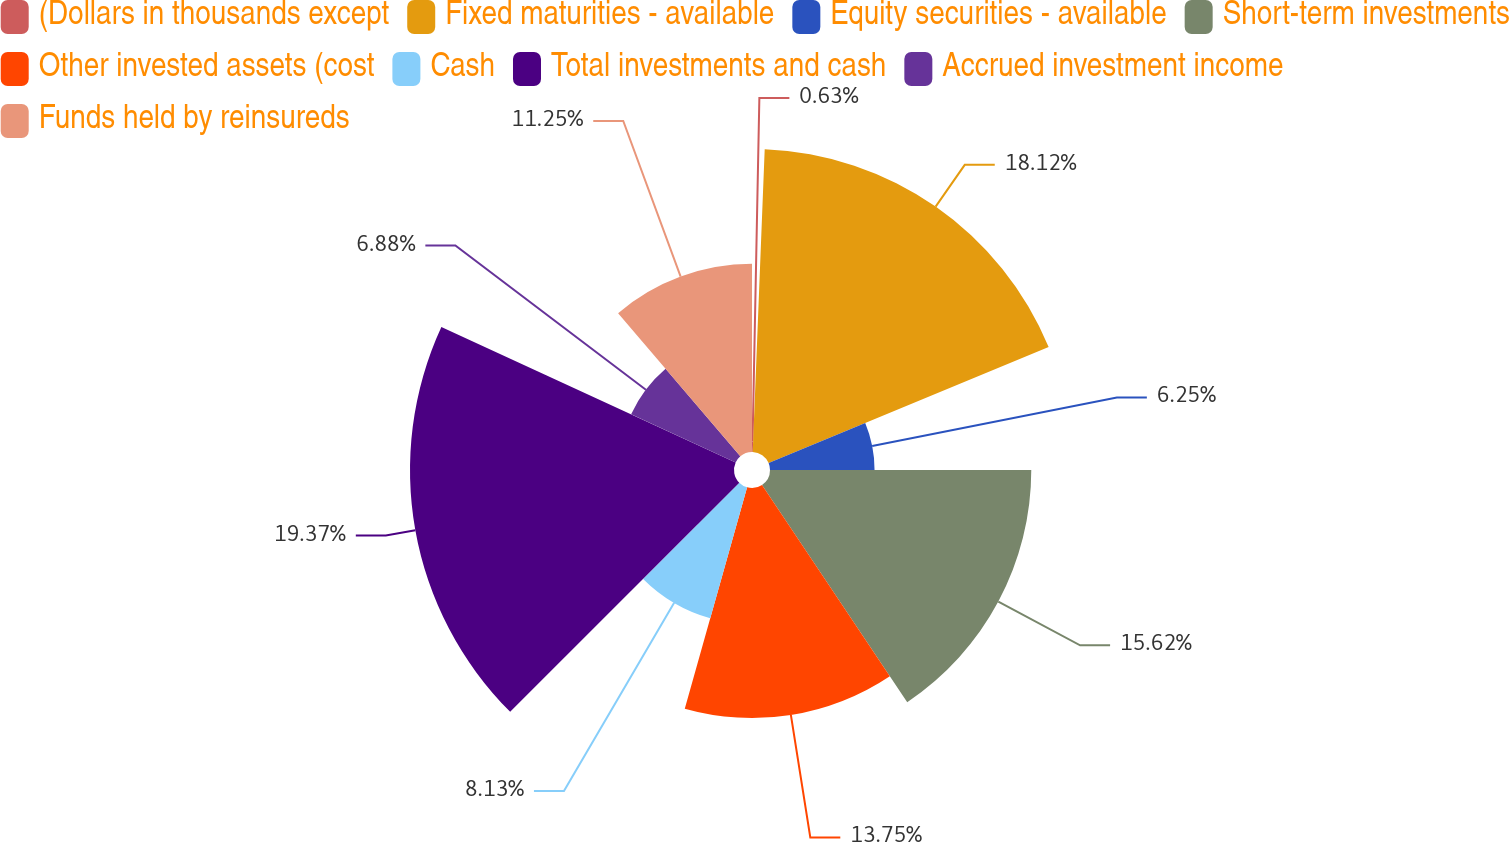<chart> <loc_0><loc_0><loc_500><loc_500><pie_chart><fcel>(Dollars in thousands except<fcel>Fixed maturities - available<fcel>Equity securities - available<fcel>Short-term investments<fcel>Other invested assets (cost<fcel>Cash<fcel>Total investments and cash<fcel>Accrued investment income<fcel>Funds held by reinsureds<nl><fcel>0.63%<fcel>18.12%<fcel>6.25%<fcel>15.62%<fcel>13.75%<fcel>8.13%<fcel>19.37%<fcel>6.88%<fcel>11.25%<nl></chart> 